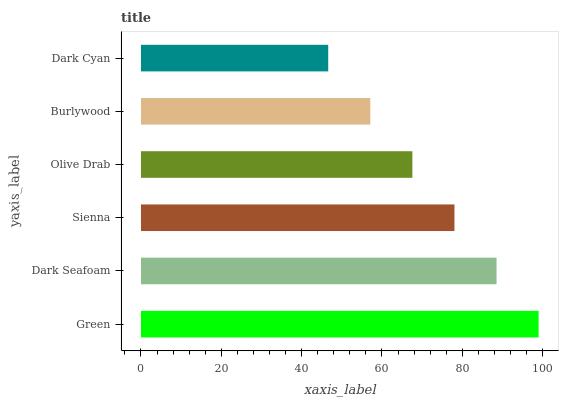Is Dark Cyan the minimum?
Answer yes or no. Yes. Is Green the maximum?
Answer yes or no. Yes. Is Dark Seafoam the minimum?
Answer yes or no. No. Is Dark Seafoam the maximum?
Answer yes or no. No. Is Green greater than Dark Seafoam?
Answer yes or no. Yes. Is Dark Seafoam less than Green?
Answer yes or no. Yes. Is Dark Seafoam greater than Green?
Answer yes or no. No. Is Green less than Dark Seafoam?
Answer yes or no. No. Is Sienna the high median?
Answer yes or no. Yes. Is Olive Drab the low median?
Answer yes or no. Yes. Is Olive Drab the high median?
Answer yes or no. No. Is Burlywood the low median?
Answer yes or no. No. 